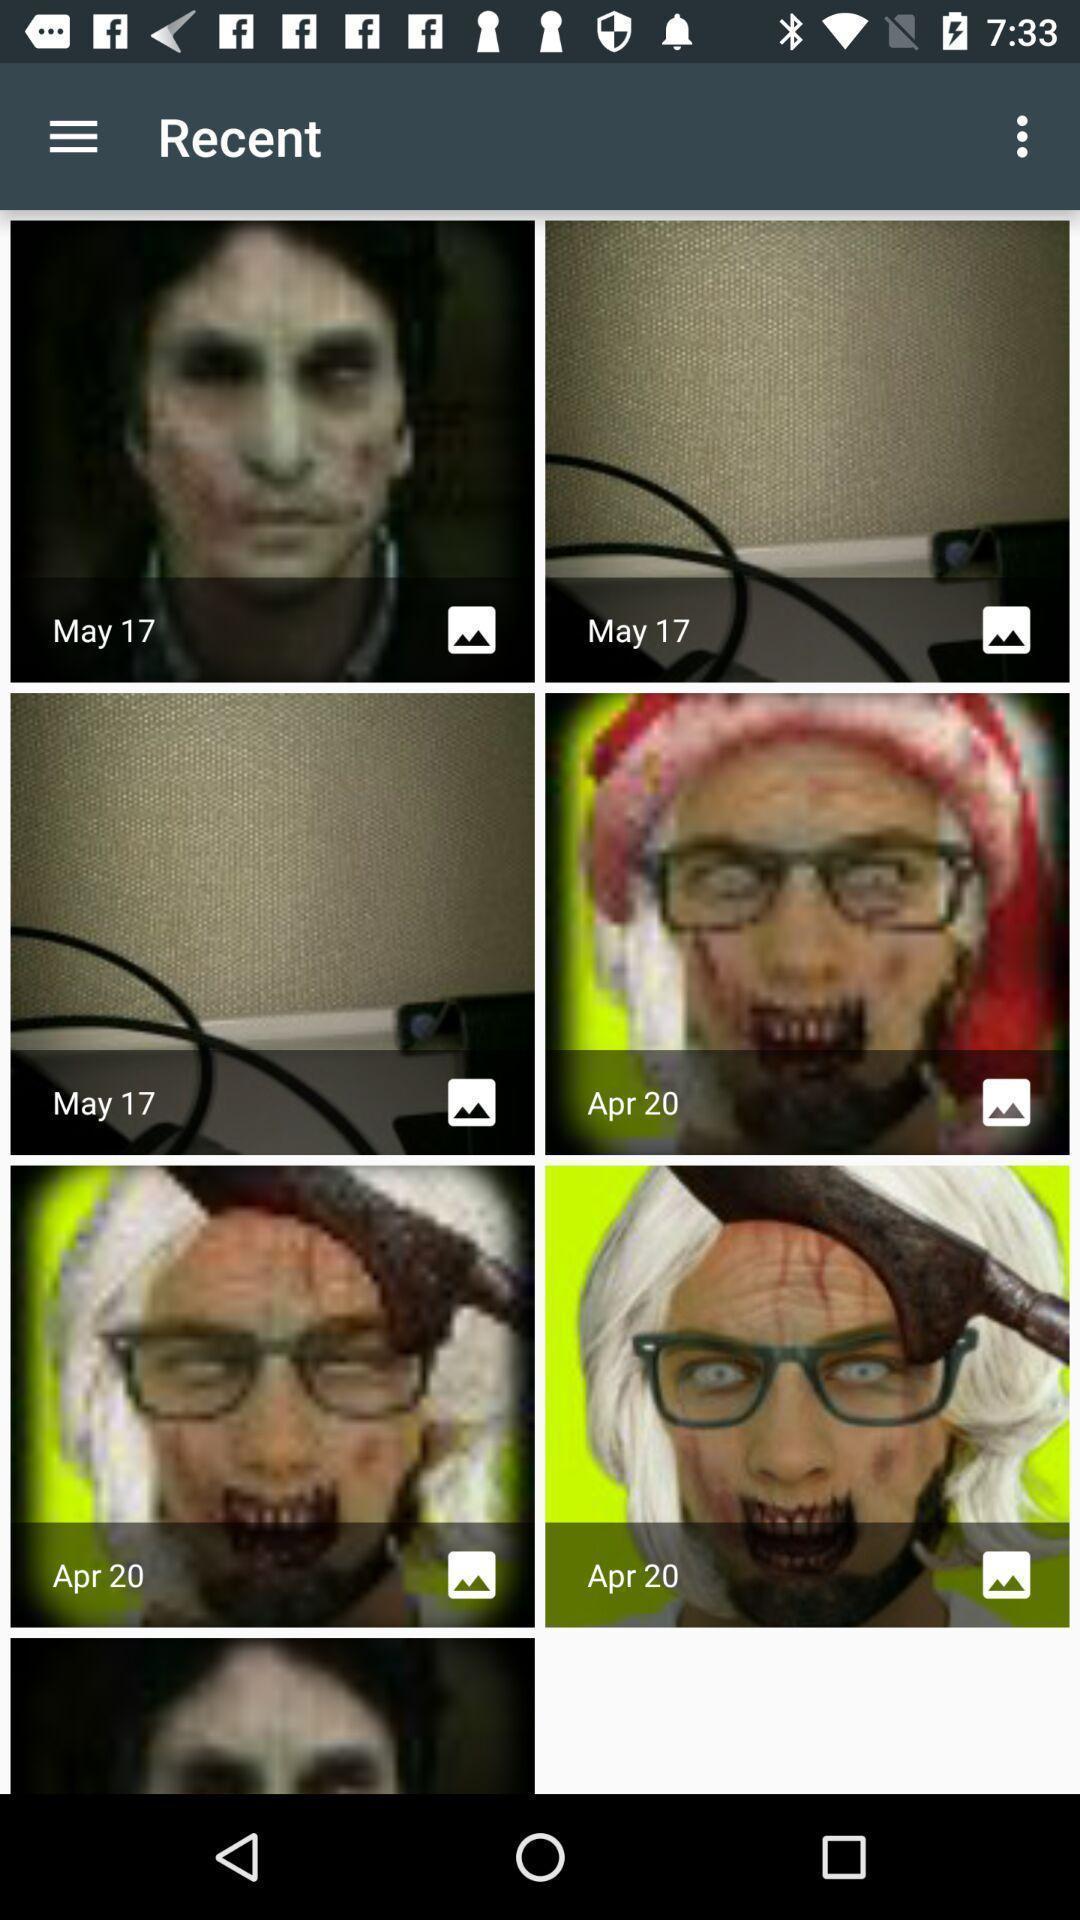Provide a textual representation of this image. Photos in recent in the album app. 